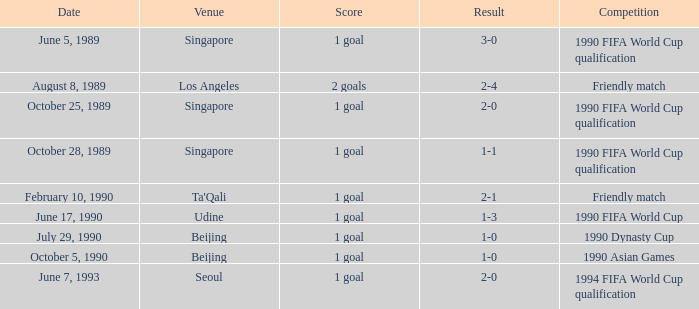At the ta'qali venue, what type of competition occurs? Friendly match. 